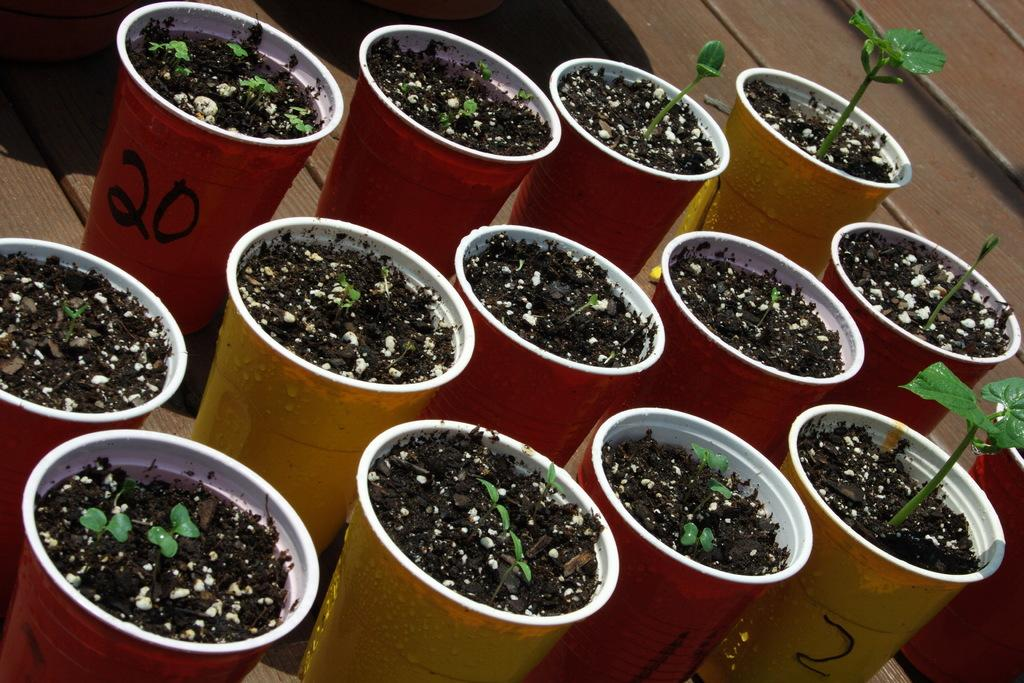What objects are present in the image related to plants? There are flower pots in the image. What colors are the flower pots? The flower pots are of different colors, specifically red and yellow. What is inside the flower pots? There is mud in the flower pots. On what surface are the flower pots placed? The flower pots are on a wooden surface. What type of glass is used to make the flower pots in the image? The flower pots in the image are not made of glass; they are made of a different material, such as clay or ceramic. How does the rake feel when touching the wooden surface in the image? There is no rake present in the image, so it cannot be used to determine how it feels when touching the wooden surface. 